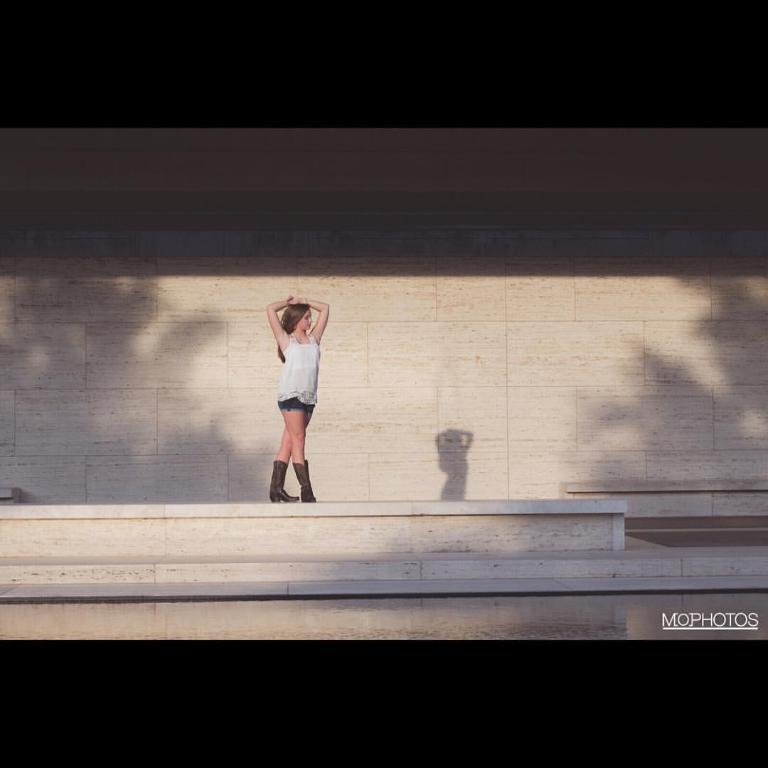Describe this image in one or two sentences. In the picture we can see a path to it, we can see a woman standing and giving a pose and she is in white top and behind her we can see a wall which is cream in color. 